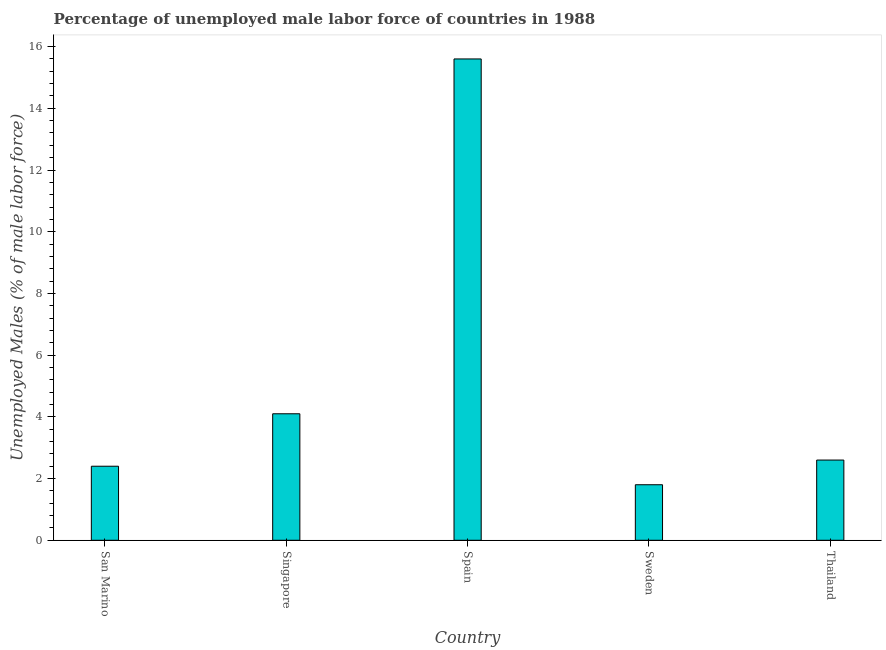Does the graph contain grids?
Provide a succinct answer. No. What is the title of the graph?
Your response must be concise. Percentage of unemployed male labor force of countries in 1988. What is the label or title of the X-axis?
Provide a succinct answer. Country. What is the label or title of the Y-axis?
Your answer should be compact. Unemployed Males (% of male labor force). What is the total unemployed male labour force in San Marino?
Offer a terse response. 2.4. Across all countries, what is the maximum total unemployed male labour force?
Your answer should be very brief. 15.6. Across all countries, what is the minimum total unemployed male labour force?
Offer a terse response. 1.8. In which country was the total unemployed male labour force maximum?
Offer a terse response. Spain. In which country was the total unemployed male labour force minimum?
Provide a short and direct response. Sweden. What is the sum of the total unemployed male labour force?
Your answer should be compact. 26.5. What is the difference between the total unemployed male labour force in San Marino and Spain?
Give a very brief answer. -13.2. What is the median total unemployed male labour force?
Provide a short and direct response. 2.6. What is the ratio of the total unemployed male labour force in Spain to that in Sweden?
Keep it short and to the point. 8.67. Is the difference between the total unemployed male labour force in Spain and Thailand greater than the difference between any two countries?
Ensure brevity in your answer.  No. What is the difference between the highest and the lowest total unemployed male labour force?
Your response must be concise. 13.8. In how many countries, is the total unemployed male labour force greater than the average total unemployed male labour force taken over all countries?
Your response must be concise. 1. How many bars are there?
Offer a terse response. 5. Are all the bars in the graph horizontal?
Make the answer very short. No. What is the difference between two consecutive major ticks on the Y-axis?
Ensure brevity in your answer.  2. What is the Unemployed Males (% of male labor force) in San Marino?
Offer a very short reply. 2.4. What is the Unemployed Males (% of male labor force) of Singapore?
Your answer should be compact. 4.1. What is the Unemployed Males (% of male labor force) of Spain?
Ensure brevity in your answer.  15.6. What is the Unemployed Males (% of male labor force) in Sweden?
Make the answer very short. 1.8. What is the Unemployed Males (% of male labor force) of Thailand?
Make the answer very short. 2.6. What is the difference between the Unemployed Males (% of male labor force) in San Marino and Spain?
Make the answer very short. -13.2. What is the difference between the Unemployed Males (% of male labor force) in San Marino and Thailand?
Give a very brief answer. -0.2. What is the difference between the Unemployed Males (% of male labor force) in Singapore and Spain?
Provide a short and direct response. -11.5. What is the difference between the Unemployed Males (% of male labor force) in Spain and Thailand?
Offer a very short reply. 13. What is the difference between the Unemployed Males (% of male labor force) in Sweden and Thailand?
Provide a short and direct response. -0.8. What is the ratio of the Unemployed Males (% of male labor force) in San Marino to that in Singapore?
Your response must be concise. 0.58. What is the ratio of the Unemployed Males (% of male labor force) in San Marino to that in Spain?
Offer a terse response. 0.15. What is the ratio of the Unemployed Males (% of male labor force) in San Marino to that in Sweden?
Ensure brevity in your answer.  1.33. What is the ratio of the Unemployed Males (% of male labor force) in San Marino to that in Thailand?
Provide a succinct answer. 0.92. What is the ratio of the Unemployed Males (% of male labor force) in Singapore to that in Spain?
Ensure brevity in your answer.  0.26. What is the ratio of the Unemployed Males (% of male labor force) in Singapore to that in Sweden?
Keep it short and to the point. 2.28. What is the ratio of the Unemployed Males (% of male labor force) in Singapore to that in Thailand?
Give a very brief answer. 1.58. What is the ratio of the Unemployed Males (% of male labor force) in Spain to that in Sweden?
Make the answer very short. 8.67. What is the ratio of the Unemployed Males (% of male labor force) in Sweden to that in Thailand?
Your answer should be very brief. 0.69. 